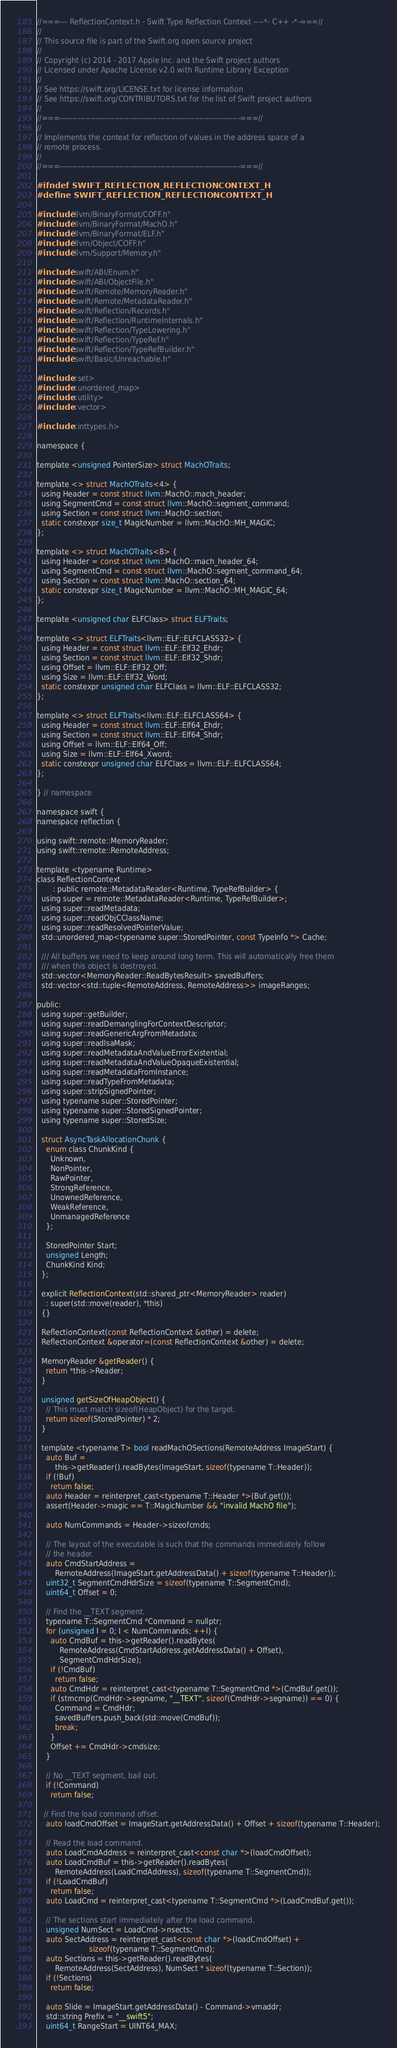Convert code to text. <code><loc_0><loc_0><loc_500><loc_500><_C_>//===--- ReflectionContext.h - Swift Type Reflection Context ----*- C++ -*-===//
//
// This source file is part of the Swift.org open source project
//
// Copyright (c) 2014 - 2017 Apple Inc. and the Swift project authors
// Licensed under Apache License v2.0 with Runtime Library Exception
//
// See https://swift.org/LICENSE.txt for license information
// See https://swift.org/CONTRIBUTORS.txt for the list of Swift project authors
//
//===----------------------------------------------------------------------===//
//
// Implements the context for reflection of values in the address space of a
// remote process.
//
//===----------------------------------------------------------------------===//

#ifndef SWIFT_REFLECTION_REFLECTIONCONTEXT_H
#define SWIFT_REFLECTION_REFLECTIONCONTEXT_H

#include "llvm/BinaryFormat/COFF.h"
#include "llvm/BinaryFormat/MachO.h"
#include "llvm/BinaryFormat/ELF.h"
#include "llvm/Object/COFF.h"
#include "llvm/Support/Memory.h"

#include "swift/ABI/Enum.h"
#include "swift/ABI/ObjectFile.h"
#include "swift/Remote/MemoryReader.h"
#include "swift/Remote/MetadataReader.h"
#include "swift/Reflection/Records.h"
#include "swift/Reflection/RuntimeInternals.h"
#include "swift/Reflection/TypeLowering.h"
#include "swift/Reflection/TypeRef.h"
#include "swift/Reflection/TypeRefBuilder.h"
#include "swift/Basic/Unreachable.h"

#include <set>
#include <unordered_map>
#include <utility>
#include <vector>

#include <inttypes.h>

namespace {

template <unsigned PointerSize> struct MachOTraits;

template <> struct MachOTraits<4> {
  using Header = const struct llvm::MachO::mach_header;
  using SegmentCmd = const struct llvm::MachO::segment_command;
  using Section = const struct llvm::MachO::section;
  static constexpr size_t MagicNumber = llvm::MachO::MH_MAGIC;
};

template <> struct MachOTraits<8> {
  using Header = const struct llvm::MachO::mach_header_64;
  using SegmentCmd = const struct llvm::MachO::segment_command_64;
  using Section = const struct llvm::MachO::section_64;
  static constexpr size_t MagicNumber = llvm::MachO::MH_MAGIC_64;
};

template <unsigned char ELFClass> struct ELFTraits;

template <> struct ELFTraits<llvm::ELF::ELFCLASS32> {
  using Header = const struct llvm::ELF::Elf32_Ehdr;
  using Section = const struct llvm::ELF::Elf32_Shdr;
  using Offset = llvm::ELF::Elf32_Off;
  using Size = llvm::ELF::Elf32_Word;
  static constexpr unsigned char ELFClass = llvm::ELF::ELFCLASS32;
};

template <> struct ELFTraits<llvm::ELF::ELFCLASS64> {
  using Header = const struct llvm::ELF::Elf64_Ehdr;
  using Section = const struct llvm::ELF::Elf64_Shdr;
  using Offset = llvm::ELF::Elf64_Off;
  using Size = llvm::ELF::Elf64_Xword;
  static constexpr unsigned char ELFClass = llvm::ELF::ELFCLASS64;
};

} // namespace

namespace swift {
namespace reflection {

using swift::remote::MemoryReader;
using swift::remote::RemoteAddress;

template <typename Runtime>
class ReflectionContext
       : public remote::MetadataReader<Runtime, TypeRefBuilder> {
  using super = remote::MetadataReader<Runtime, TypeRefBuilder>;
  using super::readMetadata;
  using super::readObjCClassName;
  using super::readResolvedPointerValue;
  std::unordered_map<typename super::StoredPointer, const TypeInfo *> Cache;

  /// All buffers we need to keep around long term. This will automatically free them
  /// when this object is destroyed.
  std::vector<MemoryReader::ReadBytesResult> savedBuffers;
  std::vector<std::tuple<RemoteAddress, RemoteAddress>> imageRanges;

public:
  using super::getBuilder;
  using super::readDemanglingForContextDescriptor;
  using super::readGenericArgFromMetadata;
  using super::readIsaMask;
  using super::readMetadataAndValueErrorExistential;
  using super::readMetadataAndValueOpaqueExistential;
  using super::readMetadataFromInstance;
  using super::readTypeFromMetadata;
  using super::stripSignedPointer;
  using typename super::StoredPointer;
  using typename super::StoredSignedPointer;
  using typename super::StoredSize;

  struct AsyncTaskAllocationChunk {
    enum class ChunkKind {
      Unknown,
      NonPointer,
      RawPointer,
      StrongReference,
      UnownedReference,
      WeakReference,
      UnmanagedReference
    };

    StoredPointer Start;
    unsigned Length;
    ChunkKind Kind;
  };

  explicit ReflectionContext(std::shared_ptr<MemoryReader> reader)
    : super(std::move(reader), *this)
  {}

  ReflectionContext(const ReflectionContext &other) = delete;
  ReflectionContext &operator=(const ReflectionContext &other) = delete;
  
  MemoryReader &getReader() {
    return *this->Reader;
  }

  unsigned getSizeOfHeapObject() {
    // This must match sizeof(HeapObject) for the target.
    return sizeof(StoredPointer) * 2;
  }

  template <typename T> bool readMachOSections(RemoteAddress ImageStart) {
    auto Buf =
        this->getReader().readBytes(ImageStart, sizeof(typename T::Header));
    if (!Buf)
      return false;
    auto Header = reinterpret_cast<typename T::Header *>(Buf.get());
    assert(Header->magic == T::MagicNumber && "invalid MachO file");

    auto NumCommands = Header->sizeofcmds;

    // The layout of the executable is such that the commands immediately follow
    // the header.
    auto CmdStartAddress =
        RemoteAddress(ImageStart.getAddressData() + sizeof(typename T::Header));
    uint32_t SegmentCmdHdrSize = sizeof(typename T::SegmentCmd);
    uint64_t Offset = 0;

    // Find the __TEXT segment.
    typename T::SegmentCmd *Command = nullptr;
    for (unsigned I = 0; I < NumCommands; ++I) {
      auto CmdBuf = this->getReader().readBytes(
          RemoteAddress(CmdStartAddress.getAddressData() + Offset),
          SegmentCmdHdrSize);
      if (!CmdBuf)
        return false;
      auto CmdHdr = reinterpret_cast<typename T::SegmentCmd *>(CmdBuf.get());
      if (strncmp(CmdHdr->segname, "__TEXT", sizeof(CmdHdr->segname)) == 0) {
        Command = CmdHdr;
        savedBuffers.push_back(std::move(CmdBuf));
        break;
      }
      Offset += CmdHdr->cmdsize;
    }

    // No __TEXT segment, bail out.
    if (!Command)
      return false;

   // Find the load command offset.
    auto loadCmdOffset = ImageStart.getAddressData() + Offset + sizeof(typename T::Header);

    // Read the load command.
    auto LoadCmdAddress = reinterpret_cast<const char *>(loadCmdOffset);
    auto LoadCmdBuf = this->getReader().readBytes(
        RemoteAddress(LoadCmdAddress), sizeof(typename T::SegmentCmd));
    if (!LoadCmdBuf)
      return false;
    auto LoadCmd = reinterpret_cast<typename T::SegmentCmd *>(LoadCmdBuf.get());

    // The sections start immediately after the load command.
    unsigned NumSect = LoadCmd->nsects;
    auto SectAddress = reinterpret_cast<const char *>(loadCmdOffset) +
                       sizeof(typename T::SegmentCmd);
    auto Sections = this->getReader().readBytes(
        RemoteAddress(SectAddress), NumSect * sizeof(typename T::Section));
    if (!Sections)
      return false;

    auto Slide = ImageStart.getAddressData() - Command->vmaddr;
    std::string Prefix = "__swift5";
    uint64_t RangeStart = UINT64_MAX;</code> 